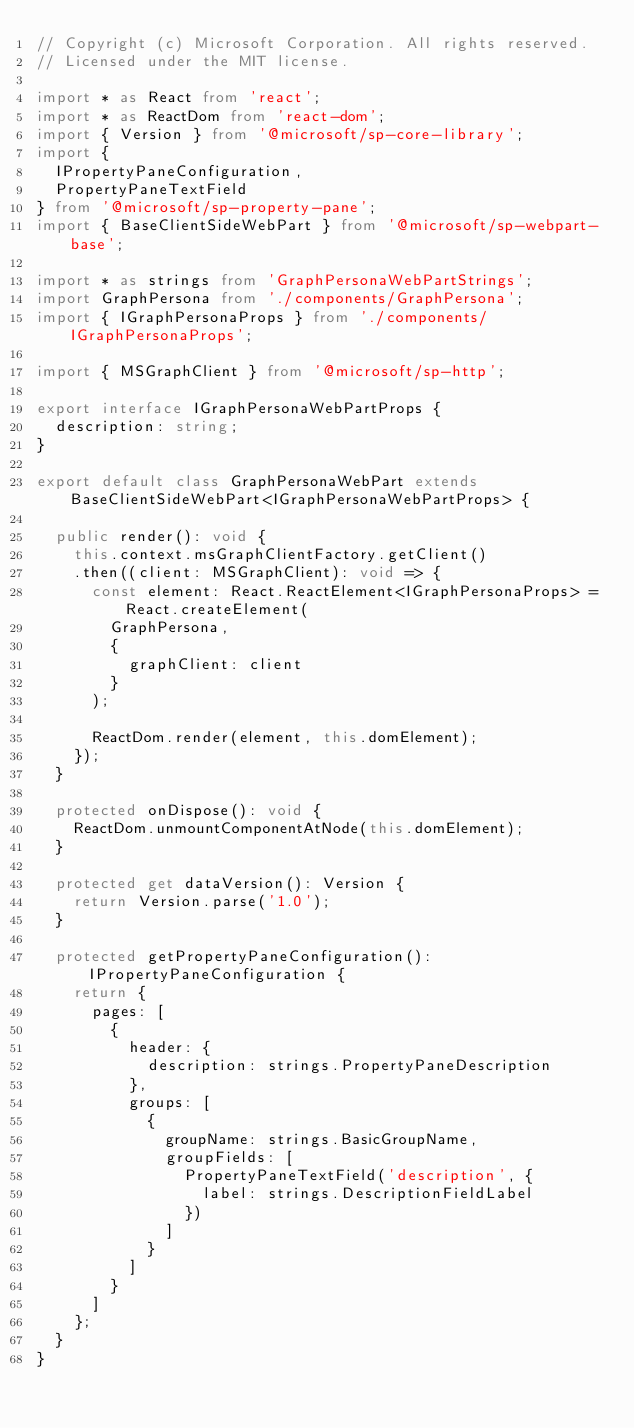<code> <loc_0><loc_0><loc_500><loc_500><_TypeScript_>// Copyright (c) Microsoft Corporation. All rights reserved.
// Licensed under the MIT license.

import * as React from 'react';
import * as ReactDom from 'react-dom';
import { Version } from '@microsoft/sp-core-library';
import {
  IPropertyPaneConfiguration,
  PropertyPaneTextField
} from '@microsoft/sp-property-pane';
import { BaseClientSideWebPart } from '@microsoft/sp-webpart-base';

import * as strings from 'GraphPersonaWebPartStrings';
import GraphPersona from './components/GraphPersona';
import { IGraphPersonaProps } from './components/IGraphPersonaProps';

import { MSGraphClient } from '@microsoft/sp-http';

export interface IGraphPersonaWebPartProps {
  description: string;
}

export default class GraphPersonaWebPart extends BaseClientSideWebPart<IGraphPersonaWebPartProps> {

  public render(): void {
    this.context.msGraphClientFactory.getClient()
    .then((client: MSGraphClient): void => {
      const element: React.ReactElement<IGraphPersonaProps> = React.createElement(
        GraphPersona,
        {
          graphClient: client
        }
      );
    
      ReactDom.render(element, this.domElement);
    });
  }

  protected onDispose(): void {
    ReactDom.unmountComponentAtNode(this.domElement);
  }

  protected get dataVersion(): Version {
    return Version.parse('1.0');
  }

  protected getPropertyPaneConfiguration(): IPropertyPaneConfiguration {
    return {
      pages: [
        {
          header: {
            description: strings.PropertyPaneDescription
          },
          groups: [
            {
              groupName: strings.BasicGroupName,
              groupFields: [
                PropertyPaneTextField('description', {
                  label: strings.DescriptionFieldLabel
                })
              ]
            }
          ]
        }
      ]
    };
  }
}
</code> 